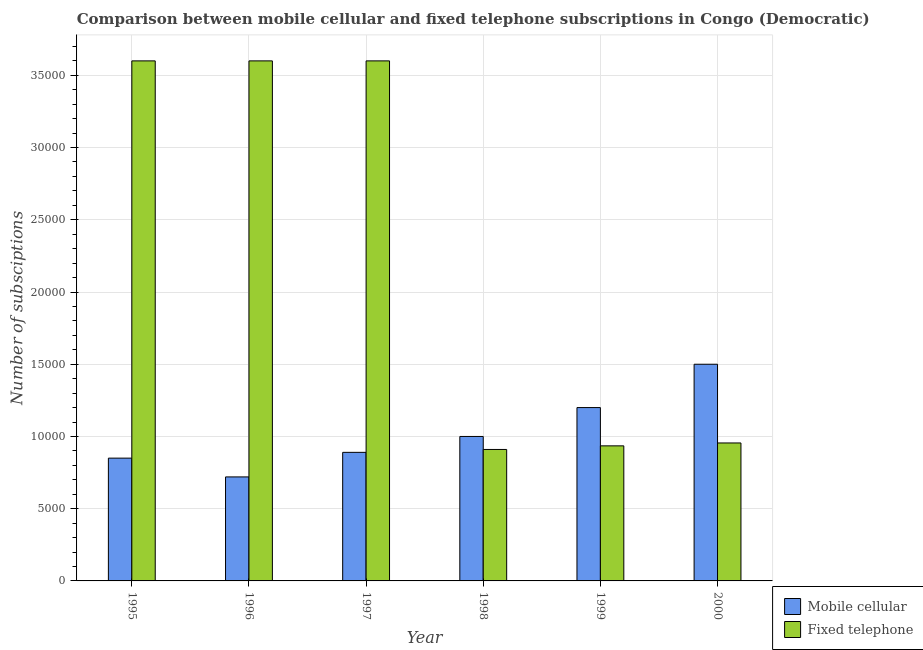How many different coloured bars are there?
Provide a succinct answer. 2. Are the number of bars on each tick of the X-axis equal?
Provide a short and direct response. Yes. How many bars are there on the 2nd tick from the left?
Give a very brief answer. 2. In how many cases, is the number of bars for a given year not equal to the number of legend labels?
Your answer should be very brief. 0. What is the number of fixed telephone subscriptions in 2000?
Offer a very short reply. 9550. Across all years, what is the maximum number of fixed telephone subscriptions?
Your answer should be very brief. 3.60e+04. Across all years, what is the minimum number of mobile cellular subscriptions?
Your response must be concise. 7200. In which year was the number of fixed telephone subscriptions minimum?
Provide a succinct answer. 1998. What is the total number of fixed telephone subscriptions in the graph?
Your answer should be very brief. 1.36e+05. What is the difference between the number of mobile cellular subscriptions in 1997 and that in 2000?
Make the answer very short. -6100. What is the difference between the number of fixed telephone subscriptions in 1995 and the number of mobile cellular subscriptions in 1998?
Provide a succinct answer. 2.69e+04. What is the average number of fixed telephone subscriptions per year?
Ensure brevity in your answer.  2.27e+04. Is the number of fixed telephone subscriptions in 1997 less than that in 1999?
Your response must be concise. No. Is the difference between the number of mobile cellular subscriptions in 1998 and 1999 greater than the difference between the number of fixed telephone subscriptions in 1998 and 1999?
Ensure brevity in your answer.  No. What is the difference between the highest and the lowest number of fixed telephone subscriptions?
Make the answer very short. 2.69e+04. What does the 1st bar from the left in 1996 represents?
Your answer should be compact. Mobile cellular. What does the 1st bar from the right in 1999 represents?
Your answer should be compact. Fixed telephone. Are all the bars in the graph horizontal?
Make the answer very short. No. Are the values on the major ticks of Y-axis written in scientific E-notation?
Provide a short and direct response. No. Does the graph contain any zero values?
Provide a succinct answer. No. Where does the legend appear in the graph?
Provide a short and direct response. Bottom right. How are the legend labels stacked?
Offer a terse response. Vertical. What is the title of the graph?
Offer a terse response. Comparison between mobile cellular and fixed telephone subscriptions in Congo (Democratic). What is the label or title of the X-axis?
Make the answer very short. Year. What is the label or title of the Y-axis?
Give a very brief answer. Number of subsciptions. What is the Number of subsciptions in Mobile cellular in 1995?
Make the answer very short. 8500. What is the Number of subsciptions in Fixed telephone in 1995?
Make the answer very short. 3.60e+04. What is the Number of subsciptions of Mobile cellular in 1996?
Provide a short and direct response. 7200. What is the Number of subsciptions of Fixed telephone in 1996?
Provide a succinct answer. 3.60e+04. What is the Number of subsciptions of Mobile cellular in 1997?
Your answer should be very brief. 8900. What is the Number of subsciptions in Fixed telephone in 1997?
Your response must be concise. 3.60e+04. What is the Number of subsciptions of Fixed telephone in 1998?
Your answer should be compact. 9100. What is the Number of subsciptions of Mobile cellular in 1999?
Your answer should be compact. 1.20e+04. What is the Number of subsciptions in Fixed telephone in 1999?
Give a very brief answer. 9350. What is the Number of subsciptions of Mobile cellular in 2000?
Your answer should be compact. 1.50e+04. What is the Number of subsciptions in Fixed telephone in 2000?
Offer a very short reply. 9550. Across all years, what is the maximum Number of subsciptions of Mobile cellular?
Make the answer very short. 1.50e+04. Across all years, what is the maximum Number of subsciptions in Fixed telephone?
Offer a very short reply. 3.60e+04. Across all years, what is the minimum Number of subsciptions of Mobile cellular?
Offer a very short reply. 7200. Across all years, what is the minimum Number of subsciptions of Fixed telephone?
Your response must be concise. 9100. What is the total Number of subsciptions in Mobile cellular in the graph?
Ensure brevity in your answer.  6.16e+04. What is the total Number of subsciptions of Fixed telephone in the graph?
Your response must be concise. 1.36e+05. What is the difference between the Number of subsciptions in Mobile cellular in 1995 and that in 1996?
Ensure brevity in your answer.  1300. What is the difference between the Number of subsciptions in Fixed telephone in 1995 and that in 1996?
Your answer should be very brief. 0. What is the difference between the Number of subsciptions of Mobile cellular in 1995 and that in 1997?
Your answer should be very brief. -400. What is the difference between the Number of subsciptions in Mobile cellular in 1995 and that in 1998?
Give a very brief answer. -1500. What is the difference between the Number of subsciptions in Fixed telephone in 1995 and that in 1998?
Your answer should be compact. 2.69e+04. What is the difference between the Number of subsciptions in Mobile cellular in 1995 and that in 1999?
Offer a very short reply. -3500. What is the difference between the Number of subsciptions in Fixed telephone in 1995 and that in 1999?
Keep it short and to the point. 2.66e+04. What is the difference between the Number of subsciptions in Mobile cellular in 1995 and that in 2000?
Offer a very short reply. -6500. What is the difference between the Number of subsciptions of Fixed telephone in 1995 and that in 2000?
Give a very brief answer. 2.64e+04. What is the difference between the Number of subsciptions in Mobile cellular in 1996 and that in 1997?
Provide a succinct answer. -1700. What is the difference between the Number of subsciptions in Mobile cellular in 1996 and that in 1998?
Provide a short and direct response. -2800. What is the difference between the Number of subsciptions of Fixed telephone in 1996 and that in 1998?
Make the answer very short. 2.69e+04. What is the difference between the Number of subsciptions of Mobile cellular in 1996 and that in 1999?
Your answer should be very brief. -4800. What is the difference between the Number of subsciptions of Fixed telephone in 1996 and that in 1999?
Your answer should be compact. 2.66e+04. What is the difference between the Number of subsciptions of Mobile cellular in 1996 and that in 2000?
Make the answer very short. -7800. What is the difference between the Number of subsciptions of Fixed telephone in 1996 and that in 2000?
Give a very brief answer. 2.64e+04. What is the difference between the Number of subsciptions of Mobile cellular in 1997 and that in 1998?
Keep it short and to the point. -1100. What is the difference between the Number of subsciptions of Fixed telephone in 1997 and that in 1998?
Give a very brief answer. 2.69e+04. What is the difference between the Number of subsciptions in Mobile cellular in 1997 and that in 1999?
Your answer should be very brief. -3100. What is the difference between the Number of subsciptions in Fixed telephone in 1997 and that in 1999?
Provide a succinct answer. 2.66e+04. What is the difference between the Number of subsciptions in Mobile cellular in 1997 and that in 2000?
Your answer should be very brief. -6100. What is the difference between the Number of subsciptions of Fixed telephone in 1997 and that in 2000?
Provide a short and direct response. 2.64e+04. What is the difference between the Number of subsciptions in Mobile cellular in 1998 and that in 1999?
Provide a short and direct response. -2000. What is the difference between the Number of subsciptions of Fixed telephone in 1998 and that in 1999?
Offer a very short reply. -250. What is the difference between the Number of subsciptions of Mobile cellular in 1998 and that in 2000?
Offer a terse response. -5000. What is the difference between the Number of subsciptions in Fixed telephone in 1998 and that in 2000?
Ensure brevity in your answer.  -450. What is the difference between the Number of subsciptions of Mobile cellular in 1999 and that in 2000?
Offer a very short reply. -3000. What is the difference between the Number of subsciptions of Fixed telephone in 1999 and that in 2000?
Your answer should be very brief. -200. What is the difference between the Number of subsciptions of Mobile cellular in 1995 and the Number of subsciptions of Fixed telephone in 1996?
Your answer should be compact. -2.75e+04. What is the difference between the Number of subsciptions in Mobile cellular in 1995 and the Number of subsciptions in Fixed telephone in 1997?
Keep it short and to the point. -2.75e+04. What is the difference between the Number of subsciptions of Mobile cellular in 1995 and the Number of subsciptions of Fixed telephone in 1998?
Give a very brief answer. -600. What is the difference between the Number of subsciptions of Mobile cellular in 1995 and the Number of subsciptions of Fixed telephone in 1999?
Your response must be concise. -850. What is the difference between the Number of subsciptions of Mobile cellular in 1995 and the Number of subsciptions of Fixed telephone in 2000?
Your answer should be very brief. -1050. What is the difference between the Number of subsciptions in Mobile cellular in 1996 and the Number of subsciptions in Fixed telephone in 1997?
Your answer should be very brief. -2.88e+04. What is the difference between the Number of subsciptions in Mobile cellular in 1996 and the Number of subsciptions in Fixed telephone in 1998?
Make the answer very short. -1900. What is the difference between the Number of subsciptions in Mobile cellular in 1996 and the Number of subsciptions in Fixed telephone in 1999?
Provide a short and direct response. -2150. What is the difference between the Number of subsciptions of Mobile cellular in 1996 and the Number of subsciptions of Fixed telephone in 2000?
Keep it short and to the point. -2350. What is the difference between the Number of subsciptions in Mobile cellular in 1997 and the Number of subsciptions in Fixed telephone in 1998?
Make the answer very short. -200. What is the difference between the Number of subsciptions of Mobile cellular in 1997 and the Number of subsciptions of Fixed telephone in 1999?
Give a very brief answer. -450. What is the difference between the Number of subsciptions of Mobile cellular in 1997 and the Number of subsciptions of Fixed telephone in 2000?
Your response must be concise. -650. What is the difference between the Number of subsciptions of Mobile cellular in 1998 and the Number of subsciptions of Fixed telephone in 1999?
Provide a succinct answer. 650. What is the difference between the Number of subsciptions of Mobile cellular in 1998 and the Number of subsciptions of Fixed telephone in 2000?
Offer a terse response. 450. What is the difference between the Number of subsciptions in Mobile cellular in 1999 and the Number of subsciptions in Fixed telephone in 2000?
Ensure brevity in your answer.  2450. What is the average Number of subsciptions in Mobile cellular per year?
Provide a succinct answer. 1.03e+04. What is the average Number of subsciptions of Fixed telephone per year?
Offer a terse response. 2.27e+04. In the year 1995, what is the difference between the Number of subsciptions in Mobile cellular and Number of subsciptions in Fixed telephone?
Make the answer very short. -2.75e+04. In the year 1996, what is the difference between the Number of subsciptions of Mobile cellular and Number of subsciptions of Fixed telephone?
Your answer should be very brief. -2.88e+04. In the year 1997, what is the difference between the Number of subsciptions of Mobile cellular and Number of subsciptions of Fixed telephone?
Keep it short and to the point. -2.71e+04. In the year 1998, what is the difference between the Number of subsciptions in Mobile cellular and Number of subsciptions in Fixed telephone?
Give a very brief answer. 900. In the year 1999, what is the difference between the Number of subsciptions of Mobile cellular and Number of subsciptions of Fixed telephone?
Provide a succinct answer. 2650. In the year 2000, what is the difference between the Number of subsciptions in Mobile cellular and Number of subsciptions in Fixed telephone?
Your answer should be very brief. 5450. What is the ratio of the Number of subsciptions in Mobile cellular in 1995 to that in 1996?
Make the answer very short. 1.18. What is the ratio of the Number of subsciptions in Mobile cellular in 1995 to that in 1997?
Keep it short and to the point. 0.96. What is the ratio of the Number of subsciptions in Fixed telephone in 1995 to that in 1997?
Give a very brief answer. 1. What is the ratio of the Number of subsciptions in Mobile cellular in 1995 to that in 1998?
Your answer should be very brief. 0.85. What is the ratio of the Number of subsciptions of Fixed telephone in 1995 to that in 1998?
Offer a terse response. 3.96. What is the ratio of the Number of subsciptions in Mobile cellular in 1995 to that in 1999?
Offer a very short reply. 0.71. What is the ratio of the Number of subsciptions in Fixed telephone in 1995 to that in 1999?
Keep it short and to the point. 3.85. What is the ratio of the Number of subsciptions in Mobile cellular in 1995 to that in 2000?
Your answer should be very brief. 0.57. What is the ratio of the Number of subsciptions of Fixed telephone in 1995 to that in 2000?
Ensure brevity in your answer.  3.77. What is the ratio of the Number of subsciptions in Mobile cellular in 1996 to that in 1997?
Offer a terse response. 0.81. What is the ratio of the Number of subsciptions of Mobile cellular in 1996 to that in 1998?
Your response must be concise. 0.72. What is the ratio of the Number of subsciptions of Fixed telephone in 1996 to that in 1998?
Offer a very short reply. 3.96. What is the ratio of the Number of subsciptions of Fixed telephone in 1996 to that in 1999?
Offer a very short reply. 3.85. What is the ratio of the Number of subsciptions in Mobile cellular in 1996 to that in 2000?
Keep it short and to the point. 0.48. What is the ratio of the Number of subsciptions in Fixed telephone in 1996 to that in 2000?
Offer a terse response. 3.77. What is the ratio of the Number of subsciptions of Mobile cellular in 1997 to that in 1998?
Provide a short and direct response. 0.89. What is the ratio of the Number of subsciptions in Fixed telephone in 1997 to that in 1998?
Make the answer very short. 3.96. What is the ratio of the Number of subsciptions in Mobile cellular in 1997 to that in 1999?
Ensure brevity in your answer.  0.74. What is the ratio of the Number of subsciptions of Fixed telephone in 1997 to that in 1999?
Keep it short and to the point. 3.85. What is the ratio of the Number of subsciptions in Mobile cellular in 1997 to that in 2000?
Provide a succinct answer. 0.59. What is the ratio of the Number of subsciptions in Fixed telephone in 1997 to that in 2000?
Give a very brief answer. 3.77. What is the ratio of the Number of subsciptions in Mobile cellular in 1998 to that in 1999?
Provide a short and direct response. 0.83. What is the ratio of the Number of subsciptions in Fixed telephone in 1998 to that in 1999?
Keep it short and to the point. 0.97. What is the ratio of the Number of subsciptions in Mobile cellular in 1998 to that in 2000?
Provide a short and direct response. 0.67. What is the ratio of the Number of subsciptions of Fixed telephone in 1998 to that in 2000?
Offer a terse response. 0.95. What is the ratio of the Number of subsciptions of Fixed telephone in 1999 to that in 2000?
Provide a succinct answer. 0.98. What is the difference between the highest and the second highest Number of subsciptions in Mobile cellular?
Offer a very short reply. 3000. What is the difference between the highest and the lowest Number of subsciptions of Mobile cellular?
Provide a succinct answer. 7800. What is the difference between the highest and the lowest Number of subsciptions of Fixed telephone?
Ensure brevity in your answer.  2.69e+04. 